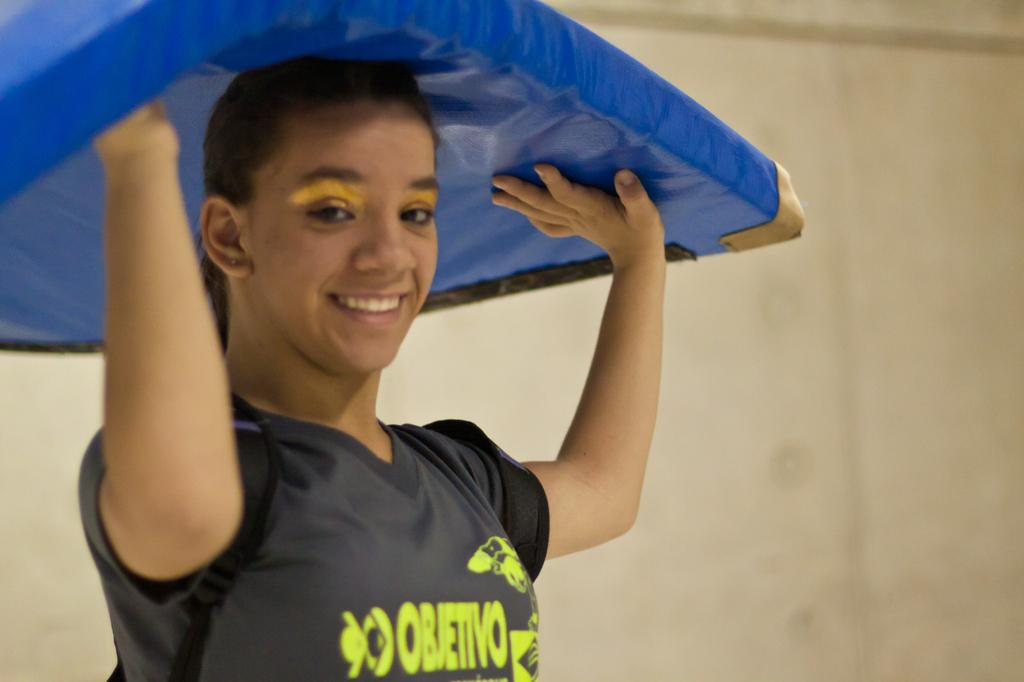What is the primary subject of the image? There is a person in the image. What is the person doing in the image? The person is standing and smiling. What is the person holding in the image? The person is holding something. What can be seen behind the person in the image? There is a wall behind the person. What type of beast can be seen climbing the mountain in the image? There is no mountain or beast present in the image; it features a person standing and smiling in front of a wall. 